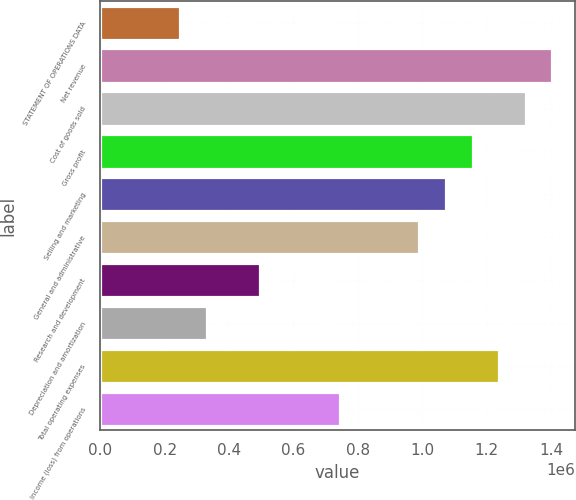<chart> <loc_0><loc_0><loc_500><loc_500><bar_chart><fcel>STATEMENT OF OPERATIONS DATA<fcel>Net revenue<fcel>Cost of goods sold<fcel>Gross profit<fcel>Selling and marketing<fcel>General and administrative<fcel>Research and development<fcel>Depreciation and amortization<fcel>Total operating expenses<fcel>Income (loss) from operations<nl><fcel>247748<fcel>1.4039e+06<fcel>1.32132e+06<fcel>1.15615e+06<fcel>1.07357e+06<fcel>990987<fcel>495494<fcel>330330<fcel>1.23873e+06<fcel>743241<nl></chart> 